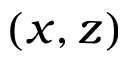<formula> <loc_0><loc_0><loc_500><loc_500>( x , z )</formula> 